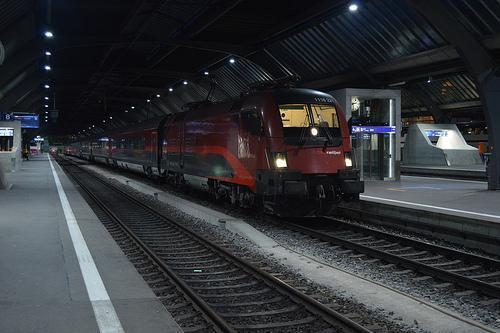How many headlamps are on the train's front?
Give a very brief answer. 3. How many tracks are at the station?
Give a very brief answer. 2. How many trains are there?
Give a very brief answer. 1. 